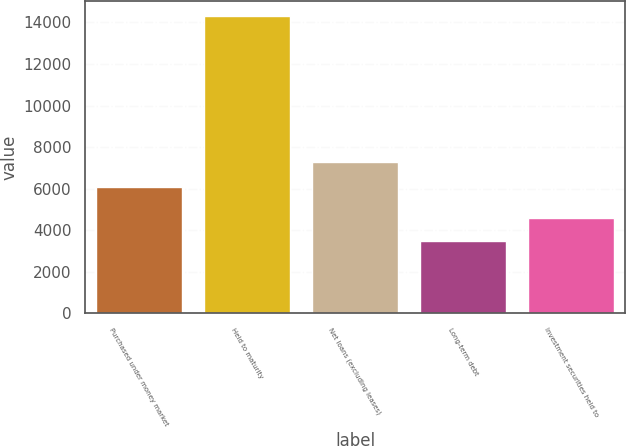<chart> <loc_0><loc_0><loc_500><loc_500><bar_chart><fcel>Purchased under money market<fcel>Held to maturity<fcel>Net loans (excluding leases)<fcel>Long-term debt<fcel>Investment securities held to<nl><fcel>6101<fcel>14311<fcel>7269<fcel>3510<fcel>4590.1<nl></chart> 